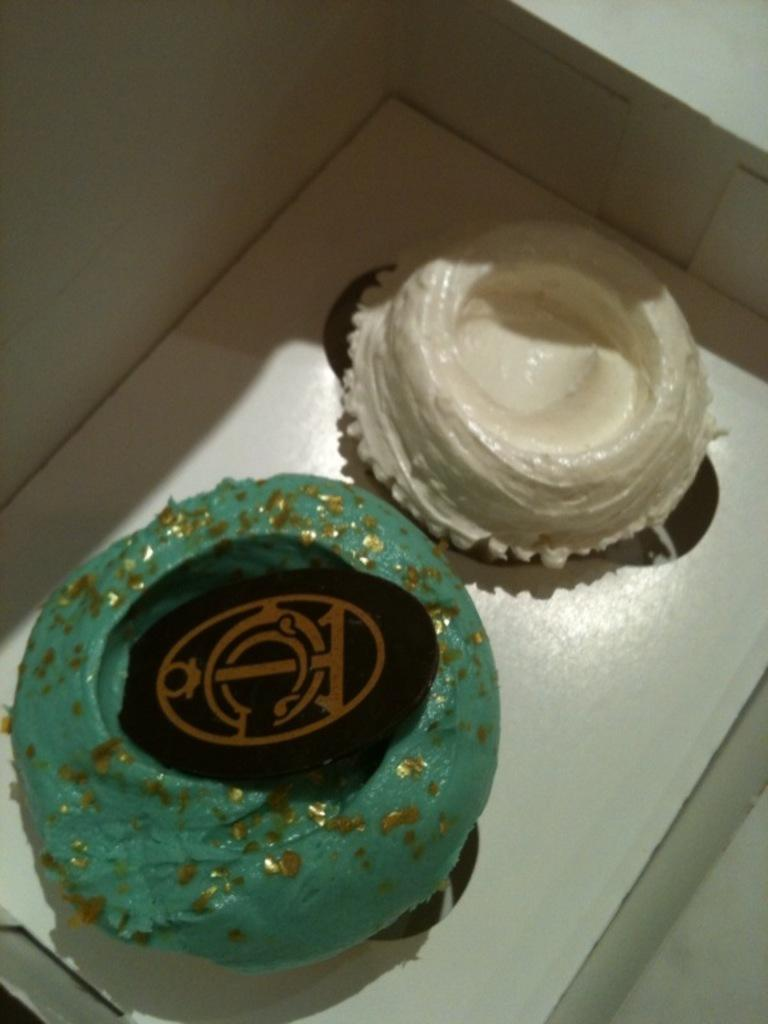What is present in the image? There is a box in the image. What can be found inside the box? There are two objects in the box. Can you describe the color of the objects in the box? One object is green in color, and the other object is white in color. How many babies are present in the image? There are no babies present in the image; it only features a box with two objects inside. 